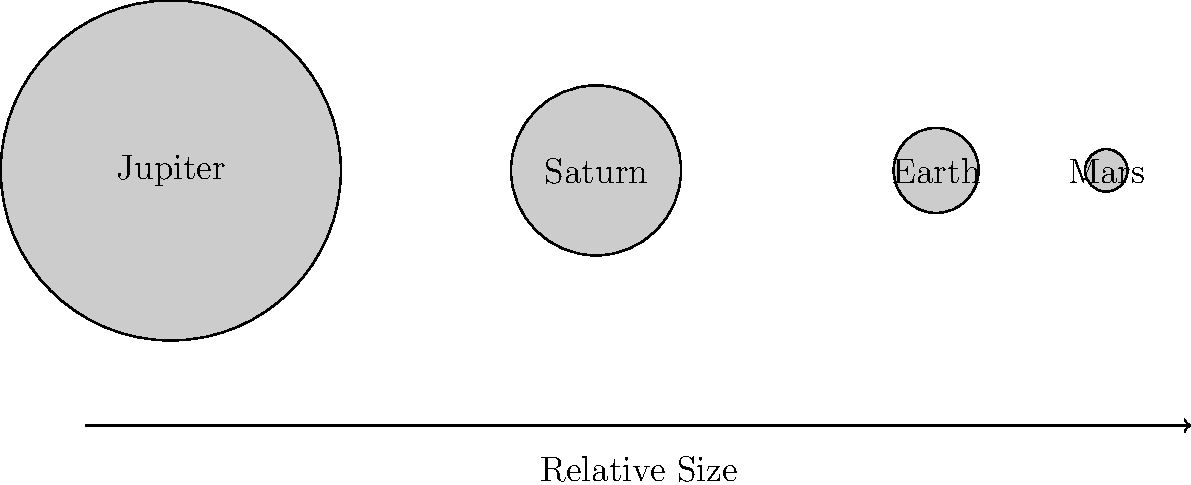In the context of comparing planetary sizes, which could be an interesting parallel to draw with the representation of women in early Finnish political movements? Consider the relative sizes of the planets shown and how this might relate to the relative influence or representation of women in different political spheres. To answer this question, let's analyze the diagram and draw parallels to the research topic:

1. The diagram shows the relative sizes of four planets: Jupiter, Saturn, Earth, and Mars.

2. Jupiter is the largest, followed by Saturn, then Earth, and finally Mars.

3. This size difference can be related to the influence or representation of women in different political spheres in early Finnish politics:

   a. Jupiter (largest) could represent the most prominent or influential political movements where women had significant roles.
   
   b. Saturn (second largest) might symbolize areas where women had moderate but still notable representation.
   
   c. Earth (smaller) could represent political spheres where women had limited but growing influence.
   
   d. Mars (smallest) might depict areas where women's representation was minimal or just beginning.

4. The relative sizes could also represent the progression of women's involvement over time, with the smaller planets representing earlier stages and larger planets representing later, more developed stages of women's political participation.

5. The arrow labeled "Relative Size" could be interpreted as a timeline of women's increasing political influence in Finland.

This parallel allows for a nuanced discussion of how women's roles and representation varied across different political movements or time periods in early Finnish politics, much like how the sizes of planets vary in our solar system.
Answer: The relative sizes of planets parallel the varying degrees of women's representation and influence in different spheres of early Finnish political movements. 